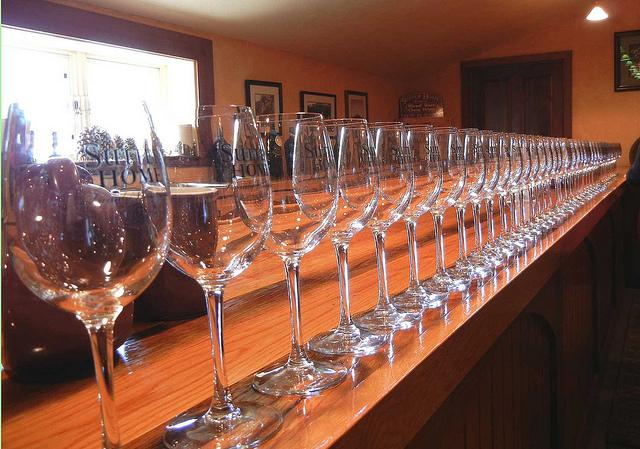What is lined up next to each other? Please explain your reasoning. wine glasses. There are no people or food items on the table. 